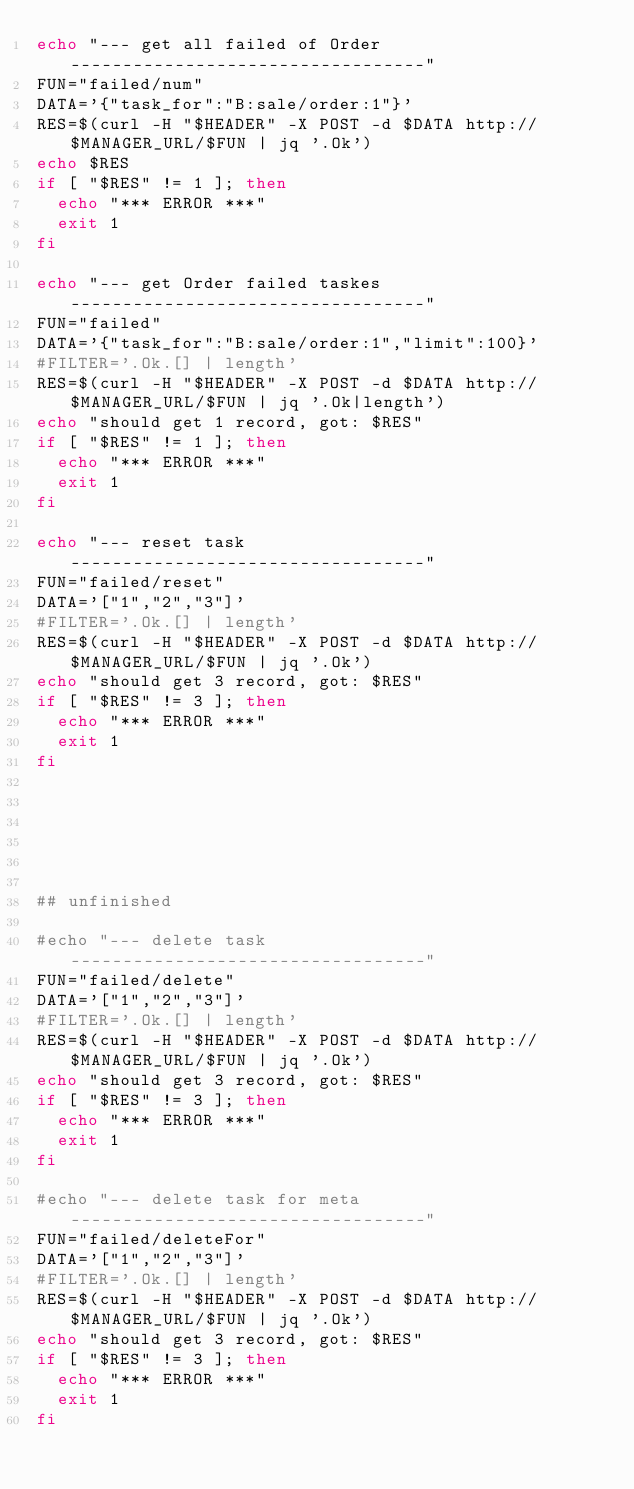<code> <loc_0><loc_0><loc_500><loc_500><_Bash_>echo "--- get all failed of Order ----------------------------------"
FUN="failed/num"
DATA='{"task_for":"B:sale/order:1"}'
RES=$(curl -H "$HEADER" -X POST -d $DATA http://$MANAGER_URL/$FUN | jq '.Ok')
echo $RES
if [ "$RES" != 1 ]; then
  echo "*** ERROR ***"
  exit 1
fi

echo "--- get Order failed taskes ----------------------------------"
FUN="failed"
DATA='{"task_for":"B:sale/order:1","limit":100}'
#FILTER='.Ok.[] | length'
RES=$(curl -H "$HEADER" -X POST -d $DATA http://$MANAGER_URL/$FUN | jq '.Ok|length')
echo "should get 1 record, got: $RES"
if [ "$RES" != 1 ]; then
  echo "*** ERROR ***"
  exit 1
fi

echo "--- reset task ----------------------------------"
FUN="failed/reset"
DATA='["1","2","3"]'
#FILTER='.Ok.[] | length'
RES=$(curl -H "$HEADER" -X POST -d $DATA http://$MANAGER_URL/$FUN | jq '.Ok')
echo "should get 3 record, got: $RES"
if [ "$RES" != 3 ]; then
  echo "*** ERROR ***"
  exit 1
fi






## unfinished

#echo "--- delete task ----------------------------------"
FUN="failed/delete"
DATA='["1","2","3"]'
#FILTER='.Ok.[] | length'
RES=$(curl -H "$HEADER" -X POST -d $DATA http://$MANAGER_URL/$FUN | jq '.Ok')
echo "should get 3 record, got: $RES"
if [ "$RES" != 3 ]; then
  echo "*** ERROR ***"
  exit 1
fi

#echo "--- delete task for meta ----------------------------------"
FUN="failed/deleteFor"
DATA='["1","2","3"]'
#FILTER='.Ok.[] | length'
RES=$(curl -H "$HEADER" -X POST -d $DATA http://$MANAGER_URL/$FUN | jq '.Ok')
echo "should get 3 record, got: $RES"
if [ "$RES" != 3 ]; then
  echo "*** ERROR ***"
  exit 1
fi

</code> 